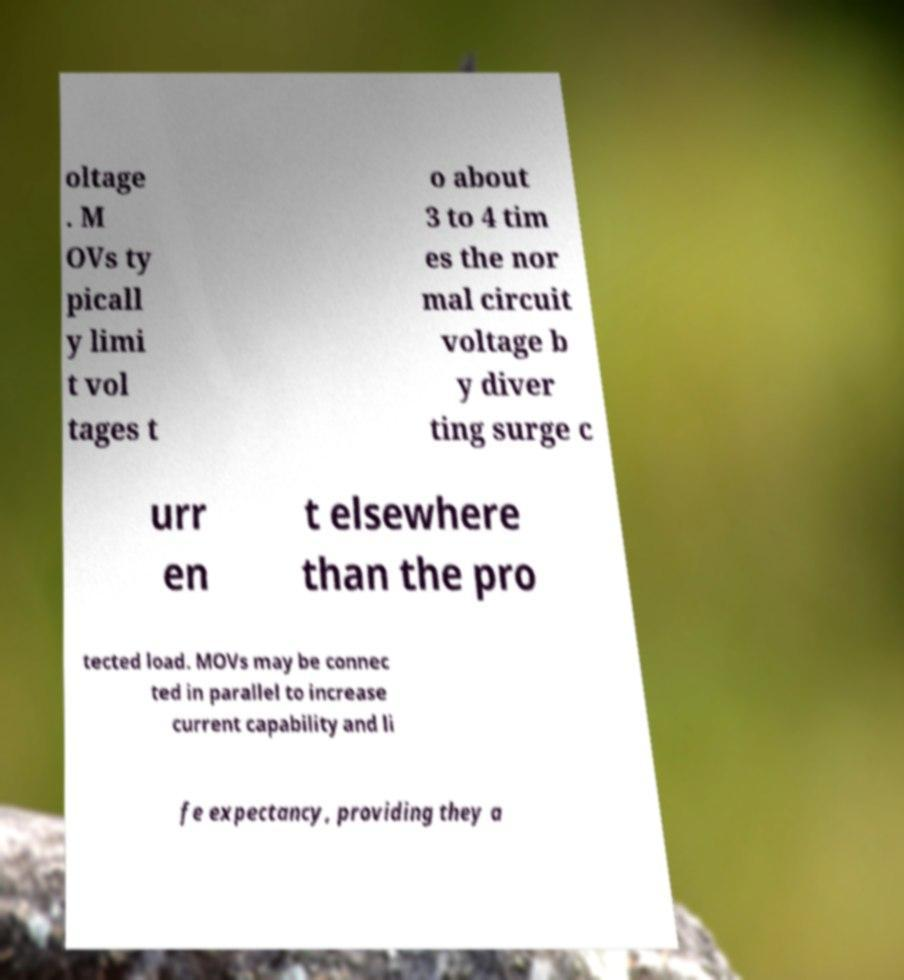For documentation purposes, I need the text within this image transcribed. Could you provide that? oltage . M OVs ty picall y limi t vol tages t o about 3 to 4 tim es the nor mal circuit voltage b y diver ting surge c urr en t elsewhere than the pro tected load. MOVs may be connec ted in parallel to increase current capability and li fe expectancy, providing they a 